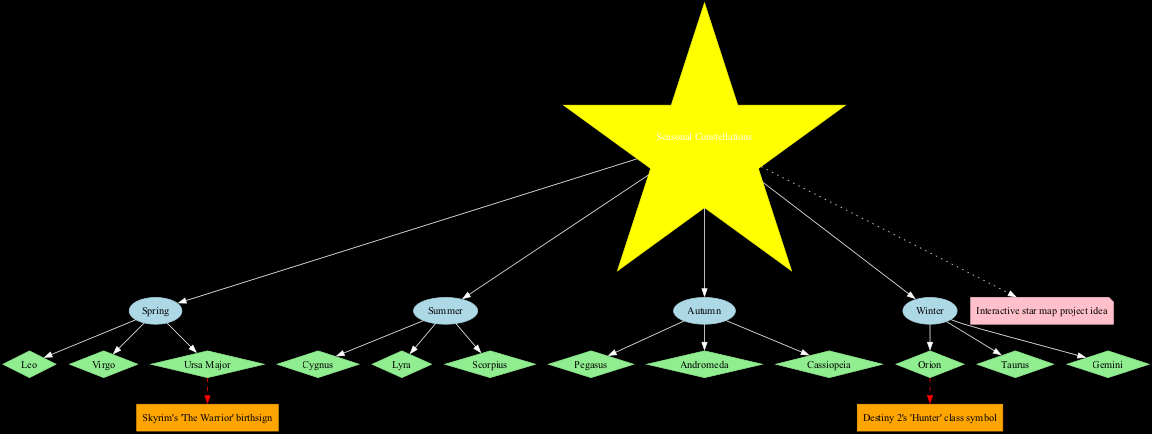What are the constellations of Summer? By locating the "Summer" node in the diagram and tracing the edge leading to its connected nodes, we find that the constellations listed under Summer are "Cygnus," "Lyra," and "Scorpius."
Answer: Cygnus, Lyra, Scorpius How many constellations are there in Autumn? The diagram shows an "Autumn" node connected to three constellations beneath it: "Pegasus," "Andromeda," and "Cassiopeia." Counting these gives a total of three constellations.
Answer: 3 Which constellation is linked to the game reference "Destiny 2's 'Hunter' class symbol"? Looking for the game reference "Destiny 2's 'Hunter' class symbol" in the diagram, we find it connected to the constellation "Orion."
Answer: Orion What are the constellations associated with Winter? To answer this, we look for the "Winter" node and examine its connected constellations, which are "Orion," "Taurus," and "Gemini."
Answer: Orion, Taurus, Gemini Which season has the constellation "Ursa Major"? Following the edge from the "Ursa Major" node, we see it is connected to the "Spring" node, indicating that "Ursa Major" belongs to the Spring season.
Answer: Spring How many seasons are represented in the diagram? The diagram features four seasons: Spring, Summer, Autumn, and Winter. Counting all the season nodes gives us a total of four.
Answer: 4 Which constellation appears in both the Winter season and as a game reference? By inspecting the Winter season node, "Orion" is noted as a constellation found there. Additionally, it has a dashed edge to the game reference "Destiny 2's 'Hunter' class symbol," indicating its dual connection.
Answer: Orion What is the color of the nodes representing constellations? The diagram shows that constellation nodes are represented in light green color, as indicated by the node attributes early in the graph settings.
Answer: light green What is the note connected to the center of the diagram? The center node is connected to a note node that states "Interactive star map project idea," as seen by tracing the edge leading to this node from the center.
Answer: Interactive star map project idea 